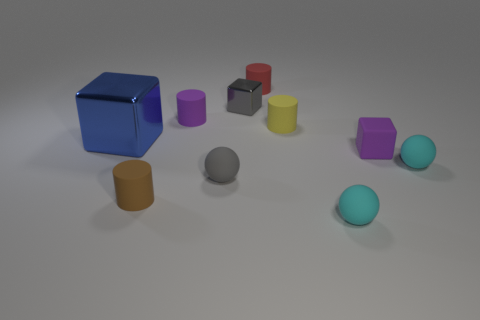Does the small purple thing left of the tiny red thing have the same shape as the tiny brown matte thing?
Your answer should be very brief. Yes. Are there any other things that have the same material as the big blue block?
Offer a very short reply. Yes. How many objects are purple matte cylinders or objects to the right of the small purple cube?
Offer a terse response. 2. There is a rubber cylinder that is behind the yellow rubber thing and on the left side of the tiny gray metal cube; what is its size?
Offer a very short reply. Small. Is the number of tiny cubes that are behind the small yellow rubber thing greater than the number of purple matte cylinders that are in front of the brown object?
Provide a short and direct response. Yes. Do the yellow object and the purple matte object that is on the left side of the yellow cylinder have the same shape?
Keep it short and to the point. Yes. How many other objects are the same shape as the small brown thing?
Provide a succinct answer. 3. There is a object that is both left of the purple cylinder and behind the small brown rubber cylinder; what color is it?
Ensure brevity in your answer.  Blue. The rubber cube has what color?
Offer a very short reply. Purple. Do the small yellow thing and the cube that is left of the small purple matte cylinder have the same material?
Provide a short and direct response. No. 